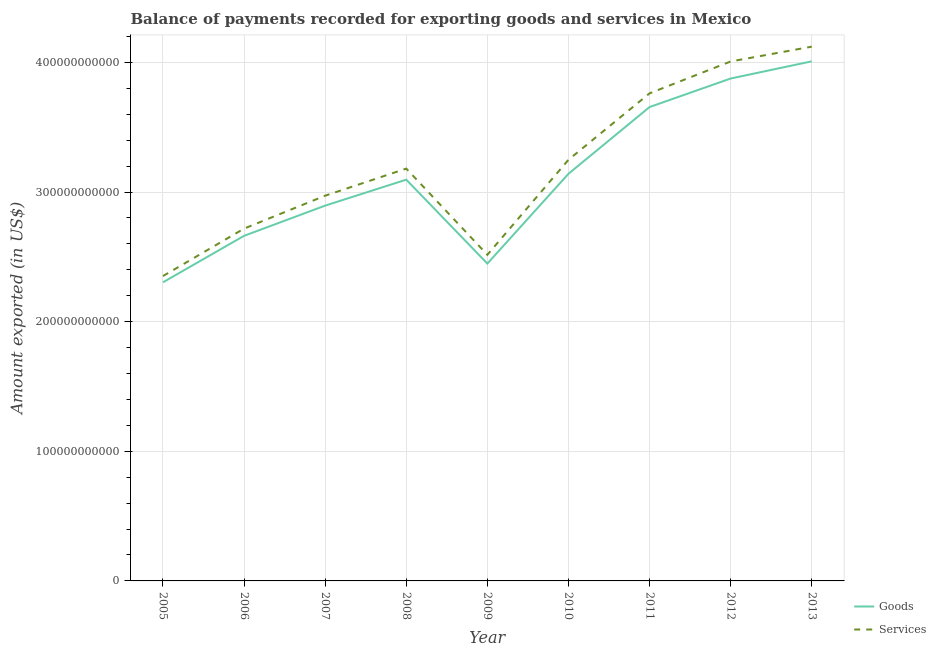How many different coloured lines are there?
Your answer should be very brief. 2. What is the amount of goods exported in 2012?
Your answer should be very brief. 3.88e+11. Across all years, what is the maximum amount of services exported?
Your answer should be very brief. 4.12e+11. Across all years, what is the minimum amount of services exported?
Ensure brevity in your answer.  2.35e+11. In which year was the amount of goods exported minimum?
Give a very brief answer. 2005. What is the total amount of goods exported in the graph?
Make the answer very short. 2.81e+12. What is the difference between the amount of services exported in 2008 and that in 2010?
Offer a terse response. -6.82e+09. What is the difference between the amount of services exported in 2008 and the amount of goods exported in 2005?
Ensure brevity in your answer.  8.77e+1. What is the average amount of goods exported per year?
Offer a terse response. 3.12e+11. In the year 2012, what is the difference between the amount of goods exported and amount of services exported?
Ensure brevity in your answer.  -1.32e+1. In how many years, is the amount of goods exported greater than 40000000000 US$?
Your response must be concise. 9. What is the ratio of the amount of goods exported in 2008 to that in 2013?
Make the answer very short. 0.77. What is the difference between the highest and the second highest amount of services exported?
Offer a very short reply. 1.14e+1. What is the difference between the highest and the lowest amount of goods exported?
Offer a very short reply. 1.70e+11. Is the sum of the amount of services exported in 2005 and 2011 greater than the maximum amount of goods exported across all years?
Offer a terse response. Yes. Is the amount of services exported strictly greater than the amount of goods exported over the years?
Your answer should be compact. Yes. Is the amount of services exported strictly less than the amount of goods exported over the years?
Give a very brief answer. No. How many years are there in the graph?
Give a very brief answer. 9. What is the difference between two consecutive major ticks on the Y-axis?
Make the answer very short. 1.00e+11. Does the graph contain grids?
Ensure brevity in your answer.  Yes. How many legend labels are there?
Provide a short and direct response. 2. What is the title of the graph?
Offer a very short reply. Balance of payments recorded for exporting goods and services in Mexico. Does "Register a business" appear as one of the legend labels in the graph?
Your response must be concise. No. What is the label or title of the X-axis?
Provide a succinct answer. Year. What is the label or title of the Y-axis?
Your answer should be compact. Amount exported (in US$). What is the Amount exported (in US$) in Goods in 2005?
Your answer should be very brief. 2.30e+11. What is the Amount exported (in US$) in Services in 2005?
Make the answer very short. 2.35e+11. What is the Amount exported (in US$) in Goods in 2006?
Ensure brevity in your answer.  2.66e+11. What is the Amount exported (in US$) of Services in 2006?
Your answer should be very brief. 2.72e+11. What is the Amount exported (in US$) in Goods in 2007?
Your answer should be very brief. 2.90e+11. What is the Amount exported (in US$) of Services in 2007?
Provide a succinct answer. 2.97e+11. What is the Amount exported (in US$) of Goods in 2008?
Give a very brief answer. 3.10e+11. What is the Amount exported (in US$) of Services in 2008?
Your answer should be compact. 3.18e+11. What is the Amount exported (in US$) in Goods in 2009?
Give a very brief answer. 2.45e+11. What is the Amount exported (in US$) of Services in 2009?
Provide a succinct answer. 2.52e+11. What is the Amount exported (in US$) in Goods in 2010?
Offer a very short reply. 3.14e+11. What is the Amount exported (in US$) in Services in 2010?
Offer a very short reply. 3.25e+11. What is the Amount exported (in US$) of Goods in 2011?
Your answer should be very brief. 3.66e+11. What is the Amount exported (in US$) of Services in 2011?
Your answer should be very brief. 3.76e+11. What is the Amount exported (in US$) of Goods in 2012?
Offer a very short reply. 3.88e+11. What is the Amount exported (in US$) in Services in 2012?
Offer a terse response. 4.01e+11. What is the Amount exported (in US$) of Goods in 2013?
Keep it short and to the point. 4.01e+11. What is the Amount exported (in US$) of Services in 2013?
Provide a succinct answer. 4.12e+11. Across all years, what is the maximum Amount exported (in US$) of Goods?
Your answer should be very brief. 4.01e+11. Across all years, what is the maximum Amount exported (in US$) in Services?
Your answer should be compact. 4.12e+11. Across all years, what is the minimum Amount exported (in US$) in Goods?
Your answer should be compact. 2.30e+11. Across all years, what is the minimum Amount exported (in US$) in Services?
Give a very brief answer. 2.35e+11. What is the total Amount exported (in US$) of Goods in the graph?
Keep it short and to the point. 2.81e+12. What is the total Amount exported (in US$) of Services in the graph?
Keep it short and to the point. 2.89e+12. What is the difference between the Amount exported (in US$) in Goods in 2005 and that in 2006?
Your answer should be very brief. -3.59e+1. What is the difference between the Amount exported (in US$) of Services in 2005 and that in 2006?
Make the answer very short. -3.66e+1. What is the difference between the Amount exported (in US$) in Goods in 2005 and that in 2007?
Your answer should be very brief. -5.92e+1. What is the difference between the Amount exported (in US$) in Services in 2005 and that in 2007?
Give a very brief answer. -6.20e+1. What is the difference between the Amount exported (in US$) of Goods in 2005 and that in 2008?
Keep it short and to the point. -7.92e+1. What is the difference between the Amount exported (in US$) in Services in 2005 and that in 2008?
Provide a succinct answer. -8.29e+1. What is the difference between the Amount exported (in US$) of Goods in 2005 and that in 2009?
Your answer should be compact. -1.44e+1. What is the difference between the Amount exported (in US$) in Services in 2005 and that in 2009?
Your response must be concise. -1.64e+1. What is the difference between the Amount exported (in US$) in Goods in 2005 and that in 2010?
Make the answer very short. -8.37e+1. What is the difference between the Amount exported (in US$) of Services in 2005 and that in 2010?
Make the answer very short. -8.97e+1. What is the difference between the Amount exported (in US$) in Goods in 2005 and that in 2011?
Provide a succinct answer. -1.35e+11. What is the difference between the Amount exported (in US$) in Services in 2005 and that in 2011?
Offer a terse response. -1.41e+11. What is the difference between the Amount exported (in US$) of Goods in 2005 and that in 2012?
Ensure brevity in your answer.  -1.57e+11. What is the difference between the Amount exported (in US$) of Services in 2005 and that in 2012?
Make the answer very short. -1.66e+11. What is the difference between the Amount exported (in US$) of Goods in 2005 and that in 2013?
Give a very brief answer. -1.70e+11. What is the difference between the Amount exported (in US$) in Services in 2005 and that in 2013?
Ensure brevity in your answer.  -1.77e+11. What is the difference between the Amount exported (in US$) of Goods in 2006 and that in 2007?
Keep it short and to the point. -2.33e+1. What is the difference between the Amount exported (in US$) of Services in 2006 and that in 2007?
Ensure brevity in your answer.  -2.54e+1. What is the difference between the Amount exported (in US$) of Goods in 2006 and that in 2008?
Give a very brief answer. -4.33e+1. What is the difference between the Amount exported (in US$) of Services in 2006 and that in 2008?
Offer a terse response. -4.63e+1. What is the difference between the Amount exported (in US$) in Goods in 2006 and that in 2009?
Offer a very short reply. 2.14e+1. What is the difference between the Amount exported (in US$) in Services in 2006 and that in 2009?
Provide a succinct answer. 2.02e+1. What is the difference between the Amount exported (in US$) in Goods in 2006 and that in 2010?
Your answer should be very brief. -4.79e+1. What is the difference between the Amount exported (in US$) in Services in 2006 and that in 2010?
Offer a very short reply. -5.31e+1. What is the difference between the Amount exported (in US$) in Goods in 2006 and that in 2011?
Provide a short and direct response. -9.94e+1. What is the difference between the Amount exported (in US$) of Services in 2006 and that in 2011?
Provide a succinct answer. -1.04e+11. What is the difference between the Amount exported (in US$) in Goods in 2006 and that in 2012?
Ensure brevity in your answer.  -1.21e+11. What is the difference between the Amount exported (in US$) of Services in 2006 and that in 2012?
Provide a succinct answer. -1.29e+11. What is the difference between the Amount exported (in US$) of Goods in 2006 and that in 2013?
Provide a short and direct response. -1.35e+11. What is the difference between the Amount exported (in US$) of Services in 2006 and that in 2013?
Offer a terse response. -1.40e+11. What is the difference between the Amount exported (in US$) in Goods in 2007 and that in 2008?
Offer a terse response. -2.00e+1. What is the difference between the Amount exported (in US$) in Services in 2007 and that in 2008?
Keep it short and to the point. -2.09e+1. What is the difference between the Amount exported (in US$) of Goods in 2007 and that in 2009?
Your answer should be very brief. 4.47e+1. What is the difference between the Amount exported (in US$) of Services in 2007 and that in 2009?
Your answer should be compact. 4.56e+1. What is the difference between the Amount exported (in US$) of Goods in 2007 and that in 2010?
Your answer should be compact. -2.46e+1. What is the difference between the Amount exported (in US$) in Services in 2007 and that in 2010?
Provide a short and direct response. -2.77e+1. What is the difference between the Amount exported (in US$) in Goods in 2007 and that in 2011?
Your response must be concise. -7.60e+1. What is the difference between the Amount exported (in US$) of Services in 2007 and that in 2011?
Keep it short and to the point. -7.90e+1. What is the difference between the Amount exported (in US$) of Goods in 2007 and that in 2012?
Make the answer very short. -9.80e+1. What is the difference between the Amount exported (in US$) in Services in 2007 and that in 2012?
Provide a short and direct response. -1.04e+11. What is the difference between the Amount exported (in US$) of Goods in 2007 and that in 2013?
Your response must be concise. -1.11e+11. What is the difference between the Amount exported (in US$) in Services in 2007 and that in 2013?
Provide a succinct answer. -1.15e+11. What is the difference between the Amount exported (in US$) of Goods in 2008 and that in 2009?
Offer a very short reply. 6.48e+1. What is the difference between the Amount exported (in US$) of Services in 2008 and that in 2009?
Your answer should be compact. 6.65e+1. What is the difference between the Amount exported (in US$) of Goods in 2008 and that in 2010?
Provide a short and direct response. -4.54e+09. What is the difference between the Amount exported (in US$) in Services in 2008 and that in 2010?
Your response must be concise. -6.82e+09. What is the difference between the Amount exported (in US$) in Goods in 2008 and that in 2011?
Make the answer very short. -5.60e+1. What is the difference between the Amount exported (in US$) of Services in 2008 and that in 2011?
Your answer should be compact. -5.81e+1. What is the difference between the Amount exported (in US$) of Goods in 2008 and that in 2012?
Make the answer very short. -7.80e+1. What is the difference between the Amount exported (in US$) of Services in 2008 and that in 2012?
Your answer should be very brief. -8.27e+1. What is the difference between the Amount exported (in US$) in Goods in 2008 and that in 2013?
Your answer should be very brief. -9.13e+1. What is the difference between the Amount exported (in US$) in Services in 2008 and that in 2013?
Provide a succinct answer. -9.41e+1. What is the difference between the Amount exported (in US$) of Goods in 2009 and that in 2010?
Offer a very short reply. -6.93e+1. What is the difference between the Amount exported (in US$) in Services in 2009 and that in 2010?
Provide a short and direct response. -7.33e+1. What is the difference between the Amount exported (in US$) in Goods in 2009 and that in 2011?
Offer a very short reply. -1.21e+11. What is the difference between the Amount exported (in US$) of Services in 2009 and that in 2011?
Keep it short and to the point. -1.25e+11. What is the difference between the Amount exported (in US$) in Goods in 2009 and that in 2012?
Your answer should be very brief. -1.43e+11. What is the difference between the Amount exported (in US$) of Services in 2009 and that in 2012?
Offer a terse response. -1.49e+11. What is the difference between the Amount exported (in US$) in Goods in 2009 and that in 2013?
Provide a short and direct response. -1.56e+11. What is the difference between the Amount exported (in US$) in Services in 2009 and that in 2013?
Your answer should be very brief. -1.61e+11. What is the difference between the Amount exported (in US$) of Goods in 2010 and that in 2011?
Offer a terse response. -5.15e+1. What is the difference between the Amount exported (in US$) of Services in 2010 and that in 2011?
Offer a terse response. -5.12e+1. What is the difference between the Amount exported (in US$) of Goods in 2010 and that in 2012?
Ensure brevity in your answer.  -7.35e+1. What is the difference between the Amount exported (in US$) of Services in 2010 and that in 2012?
Ensure brevity in your answer.  -7.58e+1. What is the difference between the Amount exported (in US$) in Goods in 2010 and that in 2013?
Your answer should be very brief. -8.68e+1. What is the difference between the Amount exported (in US$) in Services in 2010 and that in 2013?
Your response must be concise. -8.73e+1. What is the difference between the Amount exported (in US$) in Goods in 2011 and that in 2012?
Ensure brevity in your answer.  -2.20e+1. What is the difference between the Amount exported (in US$) of Services in 2011 and that in 2012?
Your response must be concise. -2.46e+1. What is the difference between the Amount exported (in US$) of Goods in 2011 and that in 2013?
Your answer should be very brief. -3.53e+1. What is the difference between the Amount exported (in US$) of Services in 2011 and that in 2013?
Your answer should be very brief. -3.60e+1. What is the difference between the Amount exported (in US$) of Goods in 2012 and that in 2013?
Your answer should be very brief. -1.33e+1. What is the difference between the Amount exported (in US$) of Services in 2012 and that in 2013?
Make the answer very short. -1.14e+1. What is the difference between the Amount exported (in US$) in Goods in 2005 and the Amount exported (in US$) in Services in 2006?
Offer a very short reply. -4.14e+1. What is the difference between the Amount exported (in US$) of Goods in 2005 and the Amount exported (in US$) of Services in 2007?
Keep it short and to the point. -6.68e+1. What is the difference between the Amount exported (in US$) in Goods in 2005 and the Amount exported (in US$) in Services in 2008?
Your answer should be very brief. -8.77e+1. What is the difference between the Amount exported (in US$) of Goods in 2005 and the Amount exported (in US$) of Services in 2009?
Provide a short and direct response. -2.12e+1. What is the difference between the Amount exported (in US$) in Goods in 2005 and the Amount exported (in US$) in Services in 2010?
Your response must be concise. -9.45e+1. What is the difference between the Amount exported (in US$) of Goods in 2005 and the Amount exported (in US$) of Services in 2011?
Provide a short and direct response. -1.46e+11. What is the difference between the Amount exported (in US$) in Goods in 2005 and the Amount exported (in US$) in Services in 2012?
Keep it short and to the point. -1.70e+11. What is the difference between the Amount exported (in US$) of Goods in 2005 and the Amount exported (in US$) of Services in 2013?
Provide a short and direct response. -1.82e+11. What is the difference between the Amount exported (in US$) of Goods in 2006 and the Amount exported (in US$) of Services in 2007?
Ensure brevity in your answer.  -3.10e+1. What is the difference between the Amount exported (in US$) of Goods in 2006 and the Amount exported (in US$) of Services in 2008?
Ensure brevity in your answer.  -5.19e+1. What is the difference between the Amount exported (in US$) of Goods in 2006 and the Amount exported (in US$) of Services in 2009?
Your answer should be very brief. 1.46e+1. What is the difference between the Amount exported (in US$) in Goods in 2006 and the Amount exported (in US$) in Services in 2010?
Your answer should be compact. -5.87e+1. What is the difference between the Amount exported (in US$) in Goods in 2006 and the Amount exported (in US$) in Services in 2011?
Make the answer very short. -1.10e+11. What is the difference between the Amount exported (in US$) of Goods in 2006 and the Amount exported (in US$) of Services in 2012?
Provide a short and direct response. -1.35e+11. What is the difference between the Amount exported (in US$) of Goods in 2006 and the Amount exported (in US$) of Services in 2013?
Keep it short and to the point. -1.46e+11. What is the difference between the Amount exported (in US$) in Goods in 2007 and the Amount exported (in US$) in Services in 2008?
Make the answer very short. -2.86e+1. What is the difference between the Amount exported (in US$) of Goods in 2007 and the Amount exported (in US$) of Services in 2009?
Your response must be concise. 3.79e+1. What is the difference between the Amount exported (in US$) of Goods in 2007 and the Amount exported (in US$) of Services in 2010?
Offer a terse response. -3.54e+1. What is the difference between the Amount exported (in US$) of Goods in 2007 and the Amount exported (in US$) of Services in 2011?
Provide a succinct answer. -8.66e+1. What is the difference between the Amount exported (in US$) in Goods in 2007 and the Amount exported (in US$) in Services in 2012?
Provide a short and direct response. -1.11e+11. What is the difference between the Amount exported (in US$) in Goods in 2007 and the Amount exported (in US$) in Services in 2013?
Your answer should be very brief. -1.23e+11. What is the difference between the Amount exported (in US$) in Goods in 2008 and the Amount exported (in US$) in Services in 2009?
Your answer should be compact. 5.80e+1. What is the difference between the Amount exported (in US$) of Goods in 2008 and the Amount exported (in US$) of Services in 2010?
Give a very brief answer. -1.53e+1. What is the difference between the Amount exported (in US$) of Goods in 2008 and the Amount exported (in US$) of Services in 2011?
Provide a succinct answer. -6.66e+1. What is the difference between the Amount exported (in US$) in Goods in 2008 and the Amount exported (in US$) in Services in 2012?
Offer a terse response. -9.12e+1. What is the difference between the Amount exported (in US$) in Goods in 2008 and the Amount exported (in US$) in Services in 2013?
Keep it short and to the point. -1.03e+11. What is the difference between the Amount exported (in US$) in Goods in 2009 and the Amount exported (in US$) in Services in 2010?
Offer a terse response. -8.01e+1. What is the difference between the Amount exported (in US$) of Goods in 2009 and the Amount exported (in US$) of Services in 2011?
Your response must be concise. -1.31e+11. What is the difference between the Amount exported (in US$) in Goods in 2009 and the Amount exported (in US$) in Services in 2012?
Your answer should be very brief. -1.56e+11. What is the difference between the Amount exported (in US$) in Goods in 2009 and the Amount exported (in US$) in Services in 2013?
Ensure brevity in your answer.  -1.67e+11. What is the difference between the Amount exported (in US$) of Goods in 2010 and the Amount exported (in US$) of Services in 2011?
Provide a succinct answer. -6.21e+1. What is the difference between the Amount exported (in US$) in Goods in 2010 and the Amount exported (in US$) in Services in 2012?
Provide a short and direct response. -8.66e+1. What is the difference between the Amount exported (in US$) of Goods in 2010 and the Amount exported (in US$) of Services in 2013?
Your answer should be compact. -9.81e+1. What is the difference between the Amount exported (in US$) in Goods in 2011 and the Amount exported (in US$) in Services in 2012?
Ensure brevity in your answer.  -3.52e+1. What is the difference between the Amount exported (in US$) of Goods in 2011 and the Amount exported (in US$) of Services in 2013?
Your answer should be compact. -4.66e+1. What is the difference between the Amount exported (in US$) of Goods in 2012 and the Amount exported (in US$) of Services in 2013?
Offer a very short reply. -2.46e+1. What is the average Amount exported (in US$) of Goods per year?
Provide a succinct answer. 3.12e+11. What is the average Amount exported (in US$) of Services per year?
Make the answer very short. 3.21e+11. In the year 2005, what is the difference between the Amount exported (in US$) in Goods and Amount exported (in US$) in Services?
Give a very brief answer. -4.82e+09. In the year 2006, what is the difference between the Amount exported (in US$) in Goods and Amount exported (in US$) in Services?
Provide a short and direct response. -5.58e+09. In the year 2007, what is the difference between the Amount exported (in US$) in Goods and Amount exported (in US$) in Services?
Offer a very short reply. -7.66e+09. In the year 2008, what is the difference between the Amount exported (in US$) of Goods and Amount exported (in US$) of Services?
Offer a very short reply. -8.53e+09. In the year 2009, what is the difference between the Amount exported (in US$) of Goods and Amount exported (in US$) of Services?
Make the answer very short. -6.80e+09. In the year 2010, what is the difference between the Amount exported (in US$) of Goods and Amount exported (in US$) of Services?
Your answer should be compact. -1.08e+1. In the year 2011, what is the difference between the Amount exported (in US$) of Goods and Amount exported (in US$) of Services?
Provide a short and direct response. -1.06e+1. In the year 2012, what is the difference between the Amount exported (in US$) of Goods and Amount exported (in US$) of Services?
Offer a terse response. -1.32e+1. In the year 2013, what is the difference between the Amount exported (in US$) of Goods and Amount exported (in US$) of Services?
Provide a short and direct response. -1.13e+1. What is the ratio of the Amount exported (in US$) in Goods in 2005 to that in 2006?
Your answer should be compact. 0.87. What is the ratio of the Amount exported (in US$) of Services in 2005 to that in 2006?
Keep it short and to the point. 0.87. What is the ratio of the Amount exported (in US$) in Goods in 2005 to that in 2007?
Ensure brevity in your answer.  0.8. What is the ratio of the Amount exported (in US$) in Services in 2005 to that in 2007?
Give a very brief answer. 0.79. What is the ratio of the Amount exported (in US$) in Goods in 2005 to that in 2008?
Keep it short and to the point. 0.74. What is the ratio of the Amount exported (in US$) of Services in 2005 to that in 2008?
Your answer should be very brief. 0.74. What is the ratio of the Amount exported (in US$) of Goods in 2005 to that in 2009?
Provide a succinct answer. 0.94. What is the ratio of the Amount exported (in US$) of Services in 2005 to that in 2009?
Provide a short and direct response. 0.93. What is the ratio of the Amount exported (in US$) in Goods in 2005 to that in 2010?
Make the answer very short. 0.73. What is the ratio of the Amount exported (in US$) in Services in 2005 to that in 2010?
Your answer should be very brief. 0.72. What is the ratio of the Amount exported (in US$) of Goods in 2005 to that in 2011?
Make the answer very short. 0.63. What is the ratio of the Amount exported (in US$) in Services in 2005 to that in 2011?
Make the answer very short. 0.63. What is the ratio of the Amount exported (in US$) of Goods in 2005 to that in 2012?
Your response must be concise. 0.59. What is the ratio of the Amount exported (in US$) of Services in 2005 to that in 2012?
Your answer should be very brief. 0.59. What is the ratio of the Amount exported (in US$) in Goods in 2005 to that in 2013?
Ensure brevity in your answer.  0.57. What is the ratio of the Amount exported (in US$) in Services in 2005 to that in 2013?
Make the answer very short. 0.57. What is the ratio of the Amount exported (in US$) in Goods in 2006 to that in 2007?
Your answer should be compact. 0.92. What is the ratio of the Amount exported (in US$) in Services in 2006 to that in 2007?
Your answer should be very brief. 0.91. What is the ratio of the Amount exported (in US$) of Goods in 2006 to that in 2008?
Your response must be concise. 0.86. What is the ratio of the Amount exported (in US$) in Services in 2006 to that in 2008?
Provide a succinct answer. 0.85. What is the ratio of the Amount exported (in US$) in Goods in 2006 to that in 2009?
Ensure brevity in your answer.  1.09. What is the ratio of the Amount exported (in US$) in Services in 2006 to that in 2009?
Offer a very short reply. 1.08. What is the ratio of the Amount exported (in US$) of Goods in 2006 to that in 2010?
Make the answer very short. 0.85. What is the ratio of the Amount exported (in US$) in Services in 2006 to that in 2010?
Provide a short and direct response. 0.84. What is the ratio of the Amount exported (in US$) of Goods in 2006 to that in 2011?
Your answer should be very brief. 0.73. What is the ratio of the Amount exported (in US$) of Services in 2006 to that in 2011?
Your answer should be compact. 0.72. What is the ratio of the Amount exported (in US$) of Goods in 2006 to that in 2012?
Make the answer very short. 0.69. What is the ratio of the Amount exported (in US$) of Services in 2006 to that in 2012?
Provide a short and direct response. 0.68. What is the ratio of the Amount exported (in US$) in Goods in 2006 to that in 2013?
Ensure brevity in your answer.  0.66. What is the ratio of the Amount exported (in US$) in Services in 2006 to that in 2013?
Provide a succinct answer. 0.66. What is the ratio of the Amount exported (in US$) of Goods in 2007 to that in 2008?
Ensure brevity in your answer.  0.94. What is the ratio of the Amount exported (in US$) in Services in 2007 to that in 2008?
Provide a short and direct response. 0.93. What is the ratio of the Amount exported (in US$) of Goods in 2007 to that in 2009?
Your response must be concise. 1.18. What is the ratio of the Amount exported (in US$) of Services in 2007 to that in 2009?
Provide a short and direct response. 1.18. What is the ratio of the Amount exported (in US$) of Goods in 2007 to that in 2010?
Provide a succinct answer. 0.92. What is the ratio of the Amount exported (in US$) in Services in 2007 to that in 2010?
Your answer should be compact. 0.91. What is the ratio of the Amount exported (in US$) of Goods in 2007 to that in 2011?
Offer a terse response. 0.79. What is the ratio of the Amount exported (in US$) of Services in 2007 to that in 2011?
Provide a short and direct response. 0.79. What is the ratio of the Amount exported (in US$) of Goods in 2007 to that in 2012?
Your response must be concise. 0.75. What is the ratio of the Amount exported (in US$) in Services in 2007 to that in 2012?
Ensure brevity in your answer.  0.74. What is the ratio of the Amount exported (in US$) of Goods in 2007 to that in 2013?
Offer a very short reply. 0.72. What is the ratio of the Amount exported (in US$) of Services in 2007 to that in 2013?
Provide a short and direct response. 0.72. What is the ratio of the Amount exported (in US$) of Goods in 2008 to that in 2009?
Your answer should be compact. 1.26. What is the ratio of the Amount exported (in US$) of Services in 2008 to that in 2009?
Make the answer very short. 1.26. What is the ratio of the Amount exported (in US$) in Goods in 2008 to that in 2010?
Offer a very short reply. 0.99. What is the ratio of the Amount exported (in US$) of Services in 2008 to that in 2010?
Provide a succinct answer. 0.98. What is the ratio of the Amount exported (in US$) of Goods in 2008 to that in 2011?
Offer a very short reply. 0.85. What is the ratio of the Amount exported (in US$) of Services in 2008 to that in 2011?
Your response must be concise. 0.85. What is the ratio of the Amount exported (in US$) of Goods in 2008 to that in 2012?
Give a very brief answer. 0.8. What is the ratio of the Amount exported (in US$) of Services in 2008 to that in 2012?
Your answer should be very brief. 0.79. What is the ratio of the Amount exported (in US$) of Goods in 2008 to that in 2013?
Give a very brief answer. 0.77. What is the ratio of the Amount exported (in US$) of Services in 2008 to that in 2013?
Give a very brief answer. 0.77. What is the ratio of the Amount exported (in US$) in Goods in 2009 to that in 2010?
Keep it short and to the point. 0.78. What is the ratio of the Amount exported (in US$) of Services in 2009 to that in 2010?
Your response must be concise. 0.77. What is the ratio of the Amount exported (in US$) of Goods in 2009 to that in 2011?
Ensure brevity in your answer.  0.67. What is the ratio of the Amount exported (in US$) in Services in 2009 to that in 2011?
Make the answer very short. 0.67. What is the ratio of the Amount exported (in US$) of Goods in 2009 to that in 2012?
Give a very brief answer. 0.63. What is the ratio of the Amount exported (in US$) of Services in 2009 to that in 2012?
Keep it short and to the point. 0.63. What is the ratio of the Amount exported (in US$) in Goods in 2009 to that in 2013?
Offer a terse response. 0.61. What is the ratio of the Amount exported (in US$) of Services in 2009 to that in 2013?
Provide a short and direct response. 0.61. What is the ratio of the Amount exported (in US$) of Goods in 2010 to that in 2011?
Provide a short and direct response. 0.86. What is the ratio of the Amount exported (in US$) in Services in 2010 to that in 2011?
Your response must be concise. 0.86. What is the ratio of the Amount exported (in US$) in Goods in 2010 to that in 2012?
Offer a terse response. 0.81. What is the ratio of the Amount exported (in US$) of Services in 2010 to that in 2012?
Make the answer very short. 0.81. What is the ratio of the Amount exported (in US$) of Goods in 2010 to that in 2013?
Provide a succinct answer. 0.78. What is the ratio of the Amount exported (in US$) of Services in 2010 to that in 2013?
Keep it short and to the point. 0.79. What is the ratio of the Amount exported (in US$) of Goods in 2011 to that in 2012?
Offer a terse response. 0.94. What is the ratio of the Amount exported (in US$) in Services in 2011 to that in 2012?
Provide a succinct answer. 0.94. What is the ratio of the Amount exported (in US$) of Goods in 2011 to that in 2013?
Offer a terse response. 0.91. What is the ratio of the Amount exported (in US$) in Services in 2011 to that in 2013?
Your response must be concise. 0.91. What is the ratio of the Amount exported (in US$) in Goods in 2012 to that in 2013?
Provide a succinct answer. 0.97. What is the ratio of the Amount exported (in US$) of Services in 2012 to that in 2013?
Your answer should be very brief. 0.97. What is the difference between the highest and the second highest Amount exported (in US$) in Goods?
Ensure brevity in your answer.  1.33e+1. What is the difference between the highest and the second highest Amount exported (in US$) in Services?
Give a very brief answer. 1.14e+1. What is the difference between the highest and the lowest Amount exported (in US$) in Goods?
Your answer should be very brief. 1.70e+11. What is the difference between the highest and the lowest Amount exported (in US$) in Services?
Your answer should be very brief. 1.77e+11. 